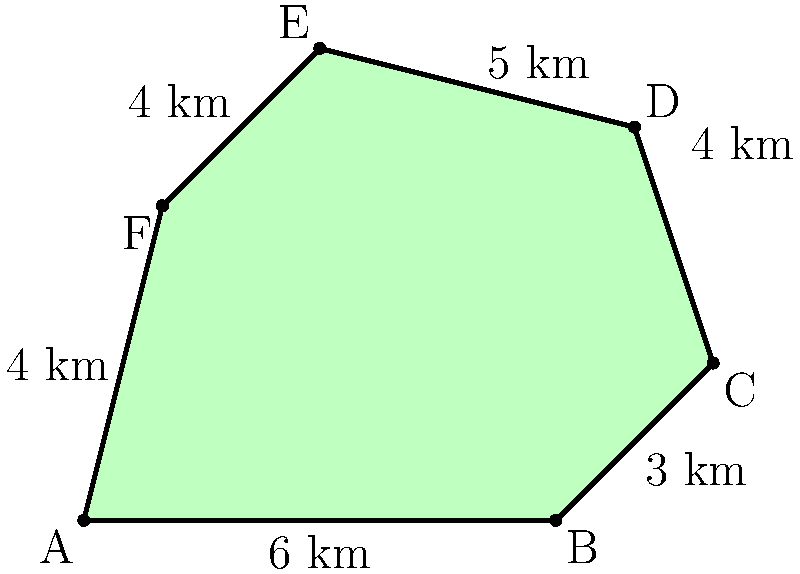As a petroleum engineer, you're tasked with calculating the area of an irregular oil field represented by the polygon ABCDEF. Given that the field is divided into triangles and the coordinates of the vertices are known, calculate the total area of the oil field in square kilometers. To calculate the area of the irregular polygon, we can use the shoelace formula (also known as the surveyor's formula). This method is particularly useful for calculating the area of an oil field with known coordinates.

The shoelace formula is given by:

$$A = \frac{1}{2}|(x_1y_2 + x_2y_3 + ... + x_ny_1) - (y_1x_2 + y_2x_3 + ... + y_nx_1)|$$

Where $(x_i, y_i)$ are the coordinates of the vertices.

Given coordinates:
A(0,0), B(6,0), C(8,2), D(7,5), E(3,6), F(1,4)

Let's apply the formula:

$$\begin{align*}
A &= \frac{1}{2}|(0\cdot0 + 6\cdot2 + 8\cdot5 + 7\cdot6 + 3\cdot4 + 1\cdot0) \\
&\quad - (0\cdot6 + 0\cdot8 + 2\cdot7 + 5\cdot3 + 6\cdot1 + 4\cdot0)| \\
&= \frac{1}{2}|(0 + 12 + 40 + 42 + 12 + 0) - (0 + 0 + 14 + 15 + 6 + 0)| \\
&= \frac{1}{2}|106 - 35| \\
&= \frac{1}{2} \cdot 71 \\
&= 35.5
\end{align*}$$

Therefore, the area of the irregular oil field is 35.5 square kilometers.
Answer: 35.5 km² 